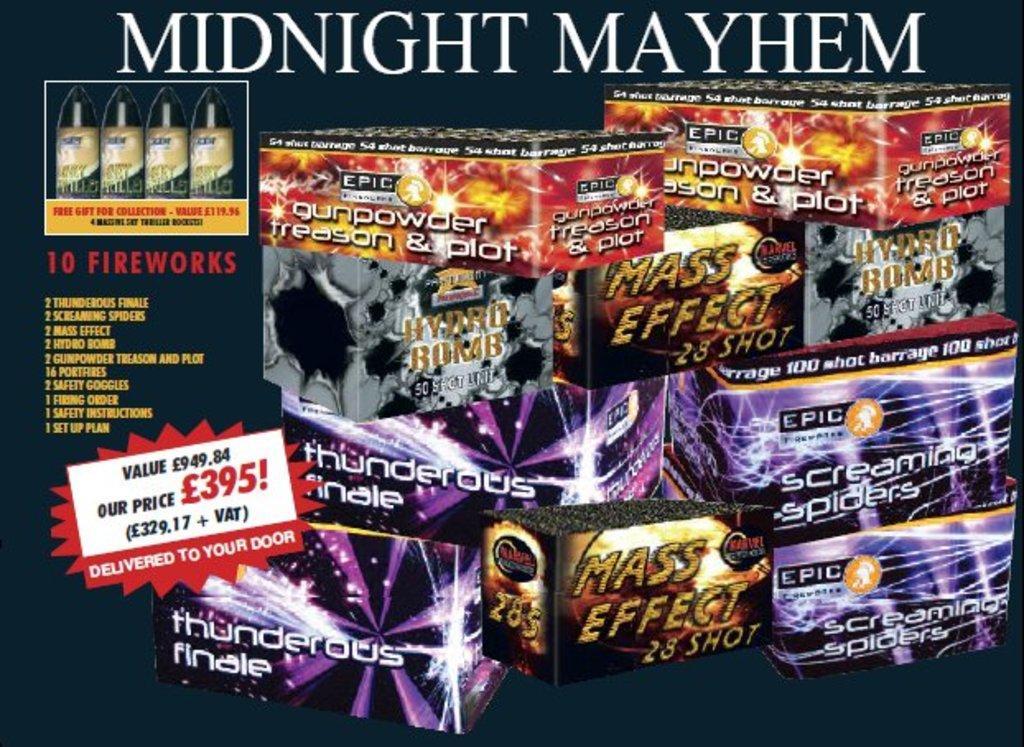Describe this image in one or two sentences. In this image there are objects, there is text, there are numbers, the background of the image is dark. 